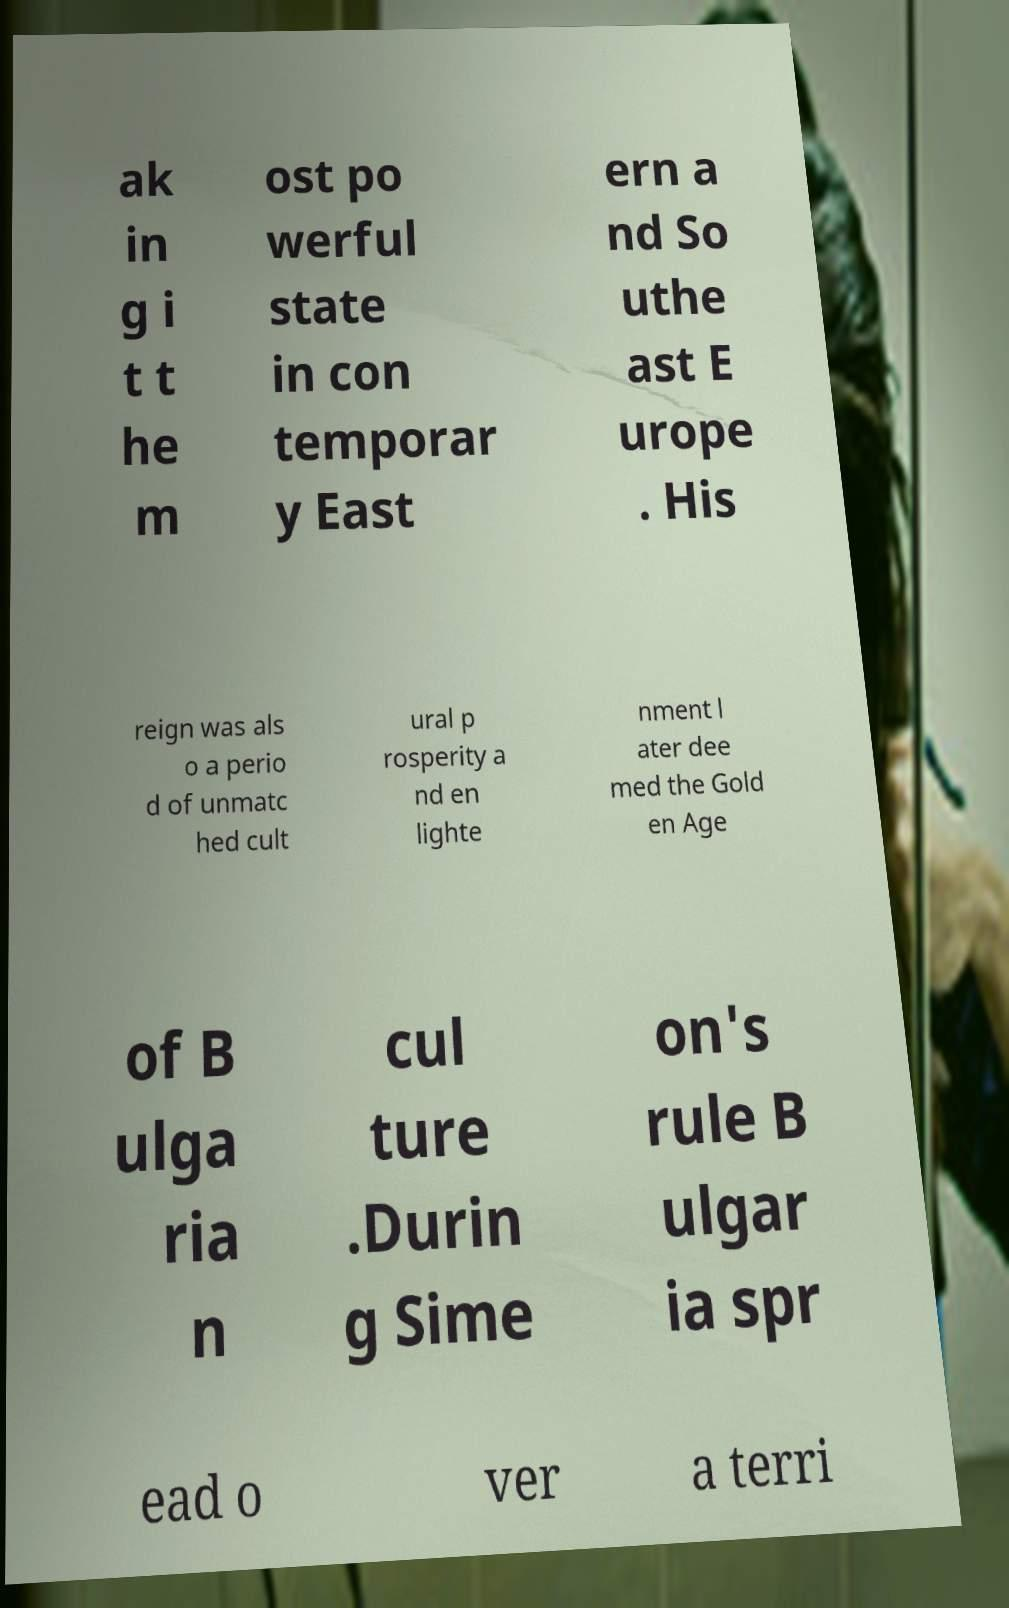Can you accurately transcribe the text from the provided image for me? ak in g i t t he m ost po werful state in con temporar y East ern a nd So uthe ast E urope . His reign was als o a perio d of unmatc hed cult ural p rosperity a nd en lighte nment l ater dee med the Gold en Age of B ulga ria n cul ture .Durin g Sime on's rule B ulgar ia spr ead o ver a terri 